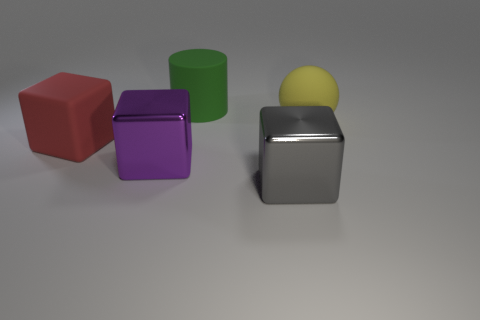Is there anything else that has the same size as the green cylinder?
Your answer should be very brief. Yes. The big cube that is to the right of the large rubber object that is behind the big yellow rubber ball is made of what material?
Give a very brief answer. Metal. How many rubber objects are yellow balls or blocks?
Give a very brief answer. 2. The other metal object that is the same shape as the purple thing is what color?
Keep it short and to the point. Gray. How many large matte things are the same color as the big cylinder?
Give a very brief answer. 0. There is a large metallic block that is to the right of the green matte cylinder; is there a shiny object behind it?
Give a very brief answer. Yes. How many matte objects are both to the right of the big purple block and left of the matte sphere?
Your answer should be compact. 1. What number of yellow spheres are made of the same material as the large purple object?
Keep it short and to the point. 0. There is a thing on the left side of the large metallic block that is to the left of the large gray metal block; how big is it?
Ensure brevity in your answer.  Large. Is there a purple metal object that has the same shape as the gray metallic object?
Offer a terse response. Yes. 